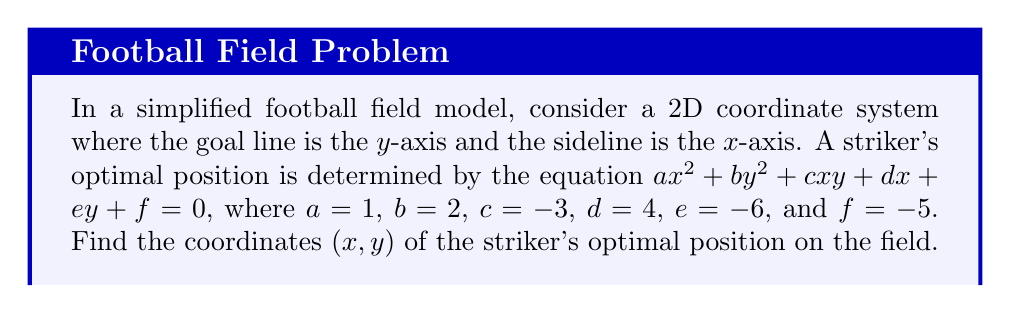Teach me how to tackle this problem. To find the optimal position, we need to follow these steps:

1) The given equation represents a conic section. Since $a \neq b$ and $c \neq 0$, it's a rotated ellipse.

2) To find the center of this ellipse (which represents the optimal position), we need to use the following formulas:

   $x_0 = \frac{2bd-ce}{c^2-4ab}$
   $y_0 = \frac{2ae-cd}{c^2-4ab}$

3) Let's substitute the given values:
   $a=1$, $b=2$, $c=-3$, $d=4$, $e=-6$

4) Calculate the denominator first:
   $c^2-4ab = (-3)^2 - 4(1)(2) = 9 - 8 = 1$

5) Now, let's calculate $x_0$:
   $x_0 = \frac{2bd-ce}{c^2-4ab} = \frac{2(2)(4)-(-3)(-6)}{1} = \frac{16-18}{1} = -2$

6) Calculate $y_0$:
   $y_0 = \frac{2ae-cd}{c^2-4ab} = \frac{2(1)(-6)-(-3)(4)}{1} = \frac{-12+12}{1} = 0$

Therefore, the optimal position for the striker is at the point $(-2,0)$ in our coordinate system.
Answer: $(-2,0)$ 